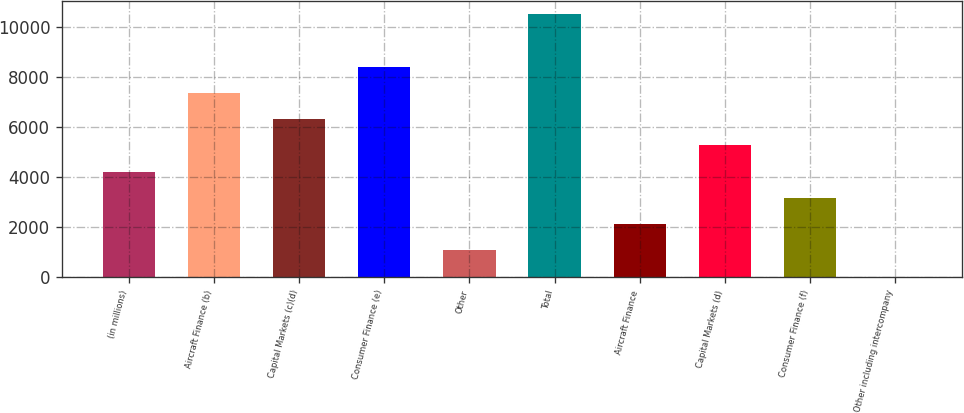<chart> <loc_0><loc_0><loc_500><loc_500><bar_chart><fcel>(in millions)<fcel>Aircraft Finance (b)<fcel>Capital Markets (c)(d)<fcel>Consumer Finance (e)<fcel>Other<fcel>Total<fcel>Aircraft Finance<fcel>Capital Markets (d)<fcel>Consumer Finance (f)<fcel>Other including intercompany<nl><fcel>4231<fcel>7378<fcel>6329<fcel>8427<fcel>1084<fcel>10525<fcel>2133<fcel>5280<fcel>3182<fcel>35<nl></chart> 